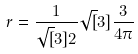Convert formula to latex. <formula><loc_0><loc_0><loc_500><loc_500>r = \frac { 1 } { \sqrt { [ } 3 ] { 2 } } \sqrt { [ } 3 ] { \frac { 3 } { 4 \pi } }</formula> 